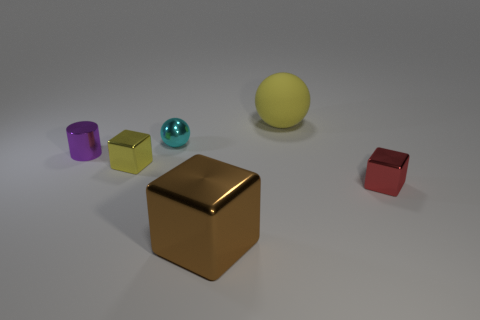Add 3 big cyan metallic cylinders. How many objects exist? 9 Subtract all spheres. How many objects are left? 4 Subtract 1 yellow balls. How many objects are left? 5 Subtract all big yellow matte cylinders. Subtract all large brown blocks. How many objects are left? 5 Add 4 cubes. How many cubes are left? 7 Add 4 cyan things. How many cyan things exist? 5 